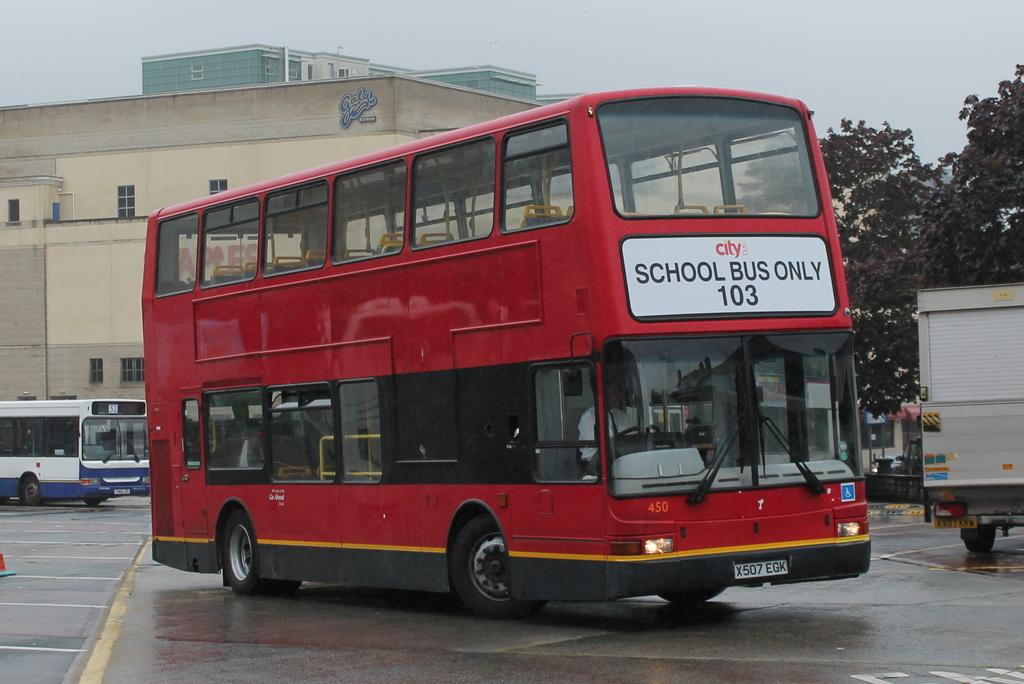<image>
Give a short and clear explanation of the subsequent image. A red double decker bus that says "School bus only" on the front of it. 